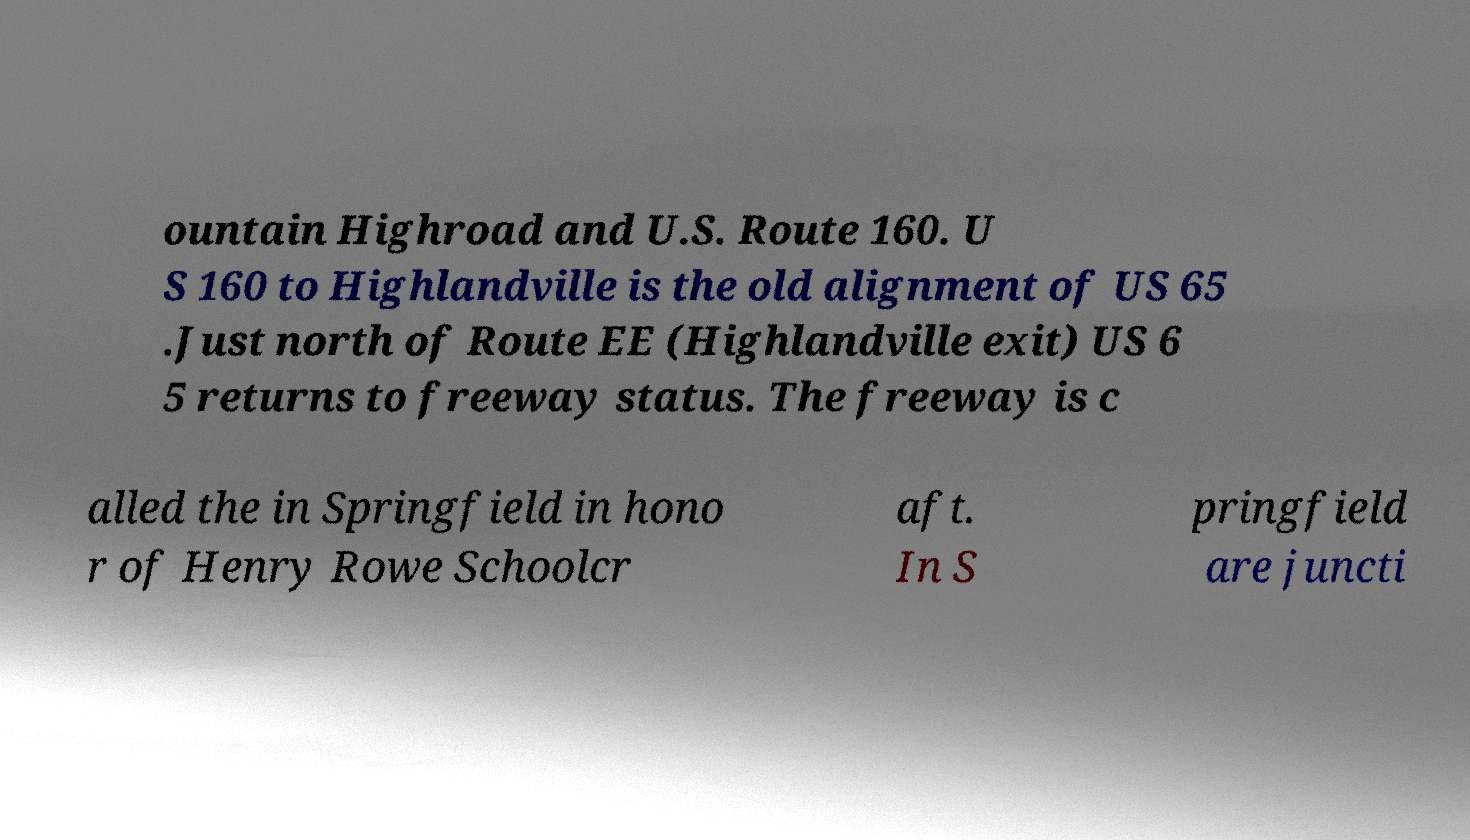Can you read and provide the text displayed in the image?This photo seems to have some interesting text. Can you extract and type it out for me? ountain Highroad and U.S. Route 160. U S 160 to Highlandville is the old alignment of US 65 .Just north of Route EE (Highlandville exit) US 6 5 returns to freeway status. The freeway is c alled the in Springfield in hono r of Henry Rowe Schoolcr aft. In S pringfield are juncti 